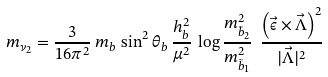Convert formula to latex. <formula><loc_0><loc_0><loc_500><loc_500>m _ { \nu _ { 2 } } = \frac { 3 } { 1 6 \pi ^ { 2 } } \, m _ { b } \, \sin ^ { 2 } \theta _ { b } \, \frac { h ^ { 2 } _ { b } } { \mu ^ { 2 } } \, \log \frac { m ^ { 2 } _ { \tilde { b } _ { 2 } } } { m ^ { 2 } _ { \tilde { b } _ { 1 } } } \ \frac { \left ( \vec { \epsilon } \times \vec { \Lambda } \right ) ^ { 2 } } { | \vec { \Lambda } | ^ { 2 } }</formula> 